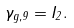Convert formula to latex. <formula><loc_0><loc_0><loc_500><loc_500>\gamma _ { g , 9 } = { I } _ { 2 } .</formula> 